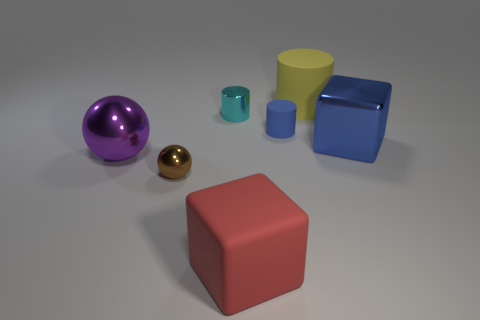Can you describe the color palette used in this image? The color palette in this image is quite varied, featuring bold and distinct hues. There's a large purple ball, a tiny shiny gold ball, a red cube, a turquoise cylinder, a yellow cone, and a blue cube, each color chosen to stand out from the others. 